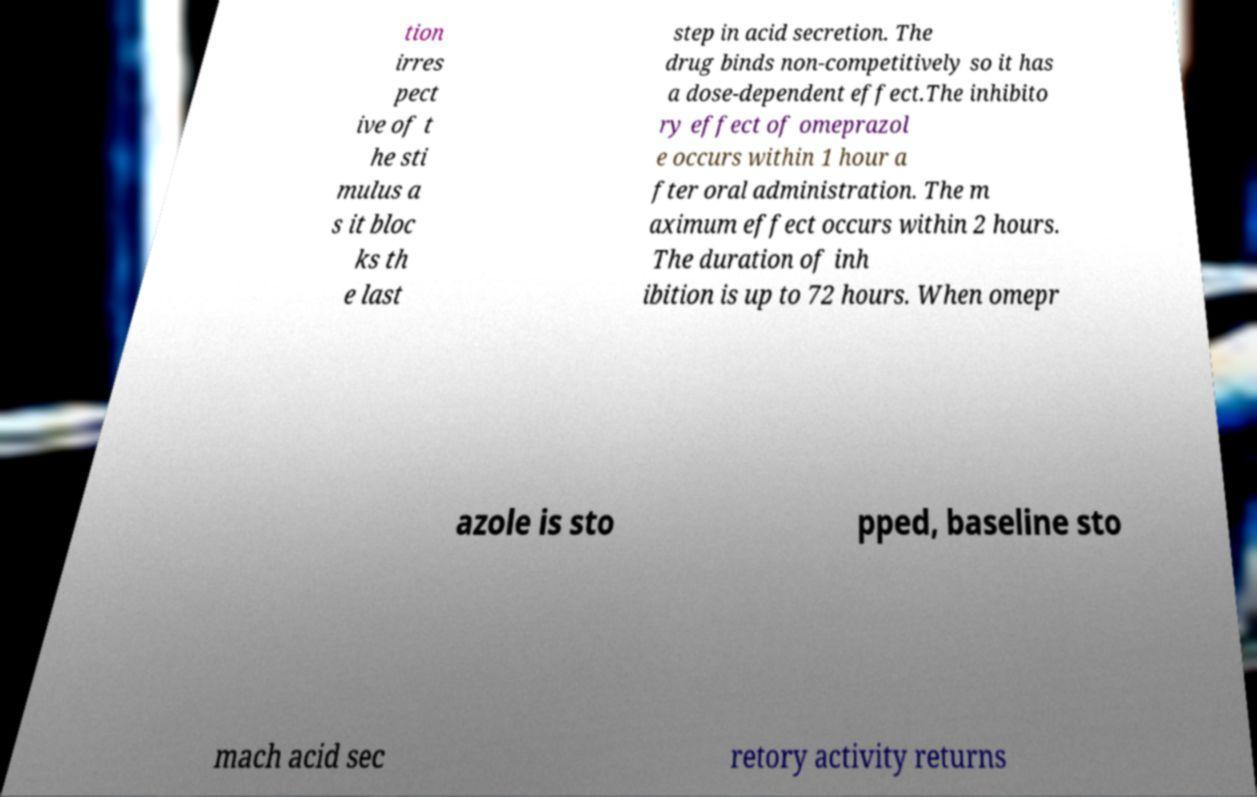I need the written content from this picture converted into text. Can you do that? tion irres pect ive of t he sti mulus a s it bloc ks th e last step in acid secretion. The drug binds non-competitively so it has a dose-dependent effect.The inhibito ry effect of omeprazol e occurs within 1 hour a fter oral administration. The m aximum effect occurs within 2 hours. The duration of inh ibition is up to 72 hours. When omepr azole is sto pped, baseline sto mach acid sec retory activity returns 